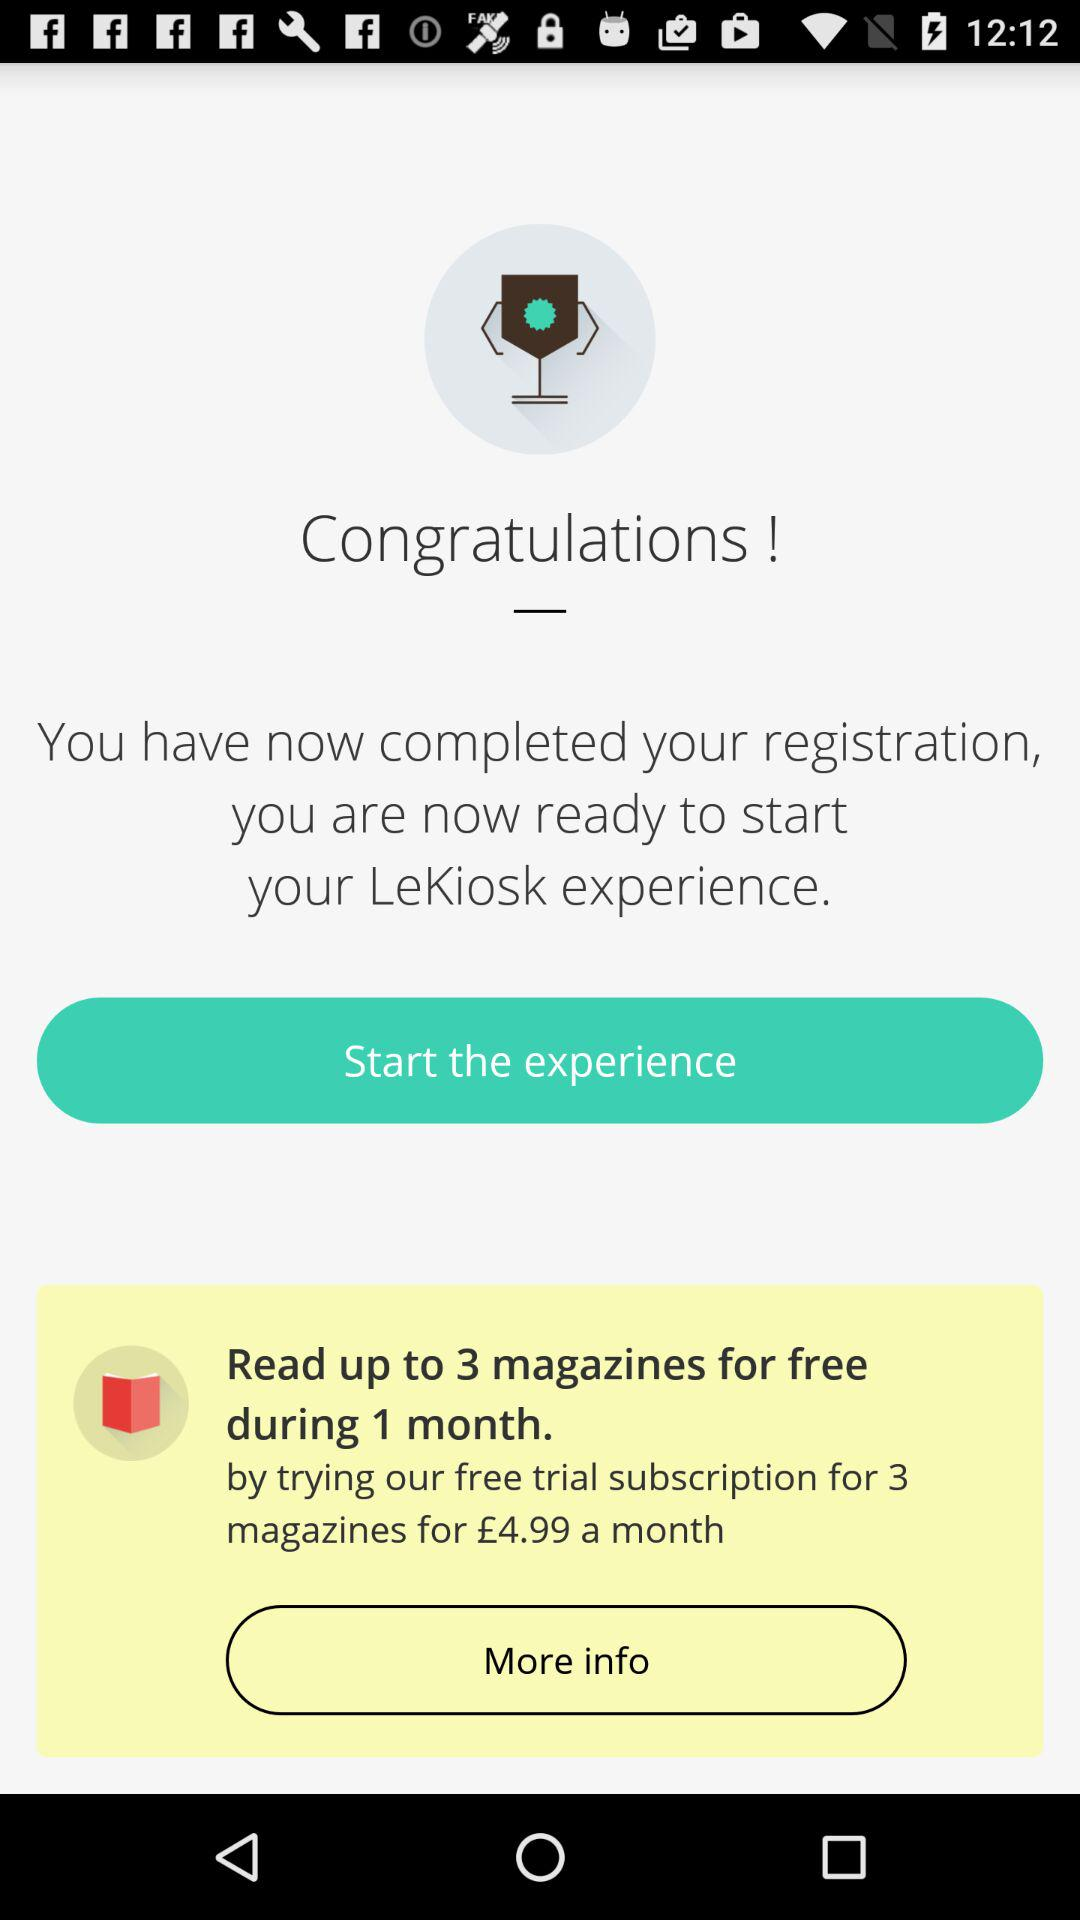What are the names of available magazines?
When the provided information is insufficient, respond with <no answer>. <no answer> 